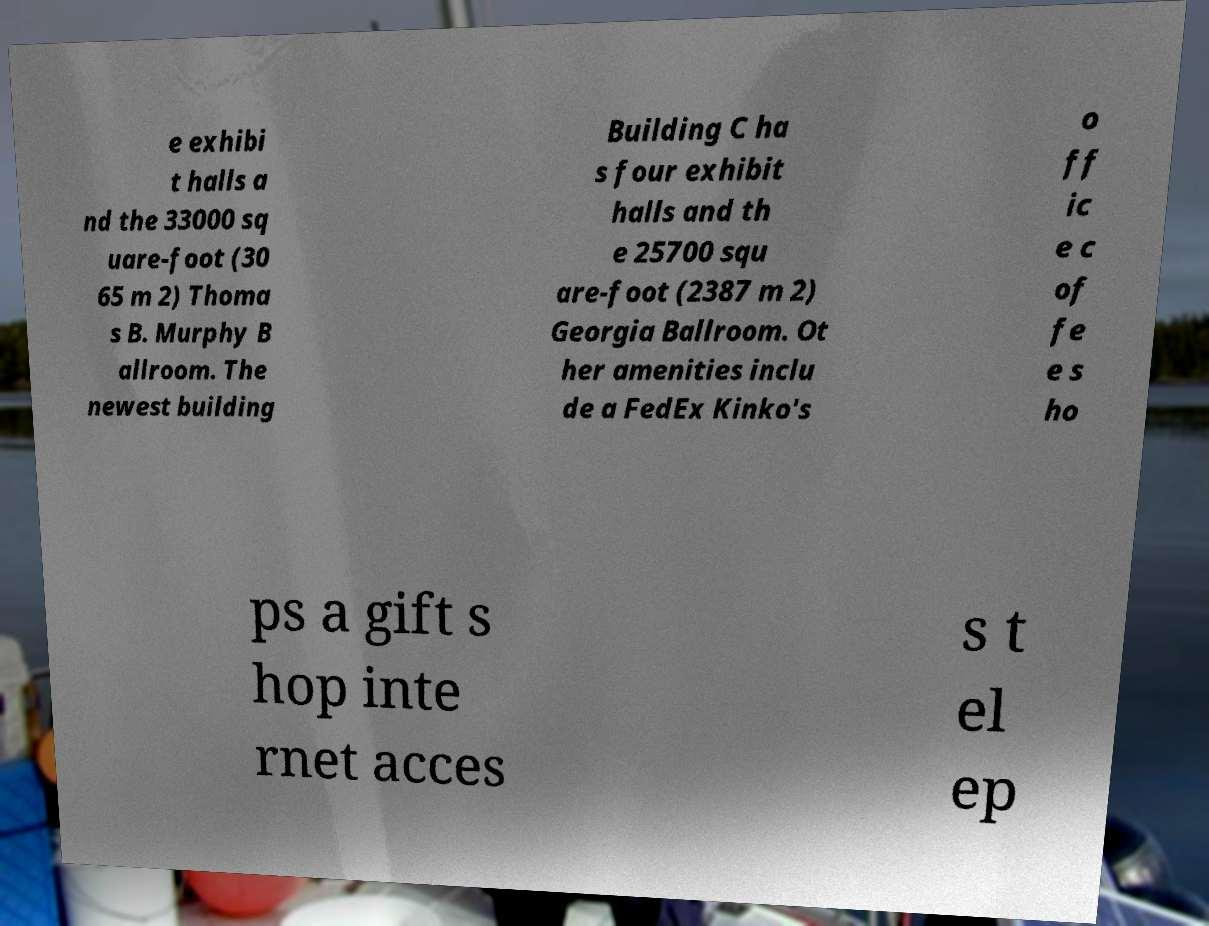Could you assist in decoding the text presented in this image and type it out clearly? e exhibi t halls a nd the 33000 sq uare-foot (30 65 m 2) Thoma s B. Murphy B allroom. The newest building Building C ha s four exhibit halls and th e 25700 squ are-foot (2387 m 2) Georgia Ballroom. Ot her amenities inclu de a FedEx Kinko's o ff ic e c of fe e s ho ps a gift s hop inte rnet acces s t el ep 